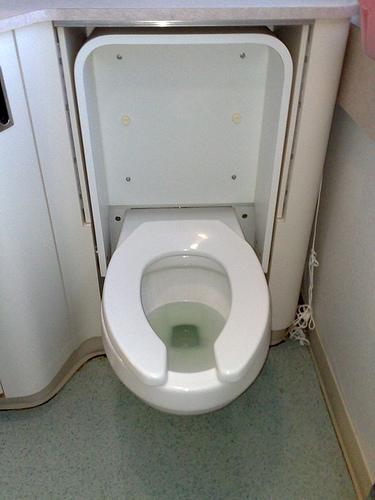What is in the toilet bowl?
Write a very short answer. Water. What room would this be?
Answer briefly. Bathroom. Does the lid match the rest of the toilet?
Concise answer only. Yes. What color is the floor?
Answer briefly. Gray. 